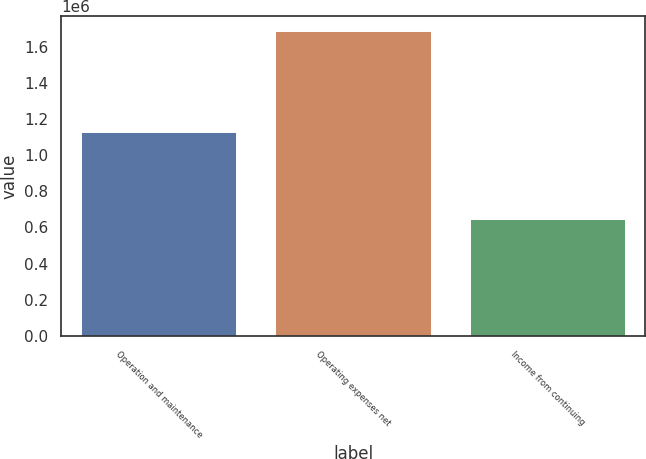Convert chart. <chart><loc_0><loc_0><loc_500><loc_500><bar_chart><fcel>Operation and maintenance<fcel>Operating expenses net<fcel>Income from continuing<nl><fcel>1.12999e+06<fcel>1.68573e+06<fcel>649117<nl></chart> 